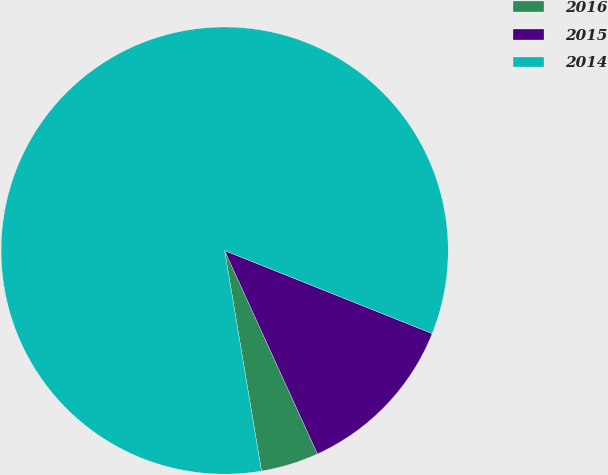<chart> <loc_0><loc_0><loc_500><loc_500><pie_chart><fcel>2016<fcel>2015<fcel>2014<nl><fcel>4.18%<fcel>12.13%<fcel>83.68%<nl></chart> 